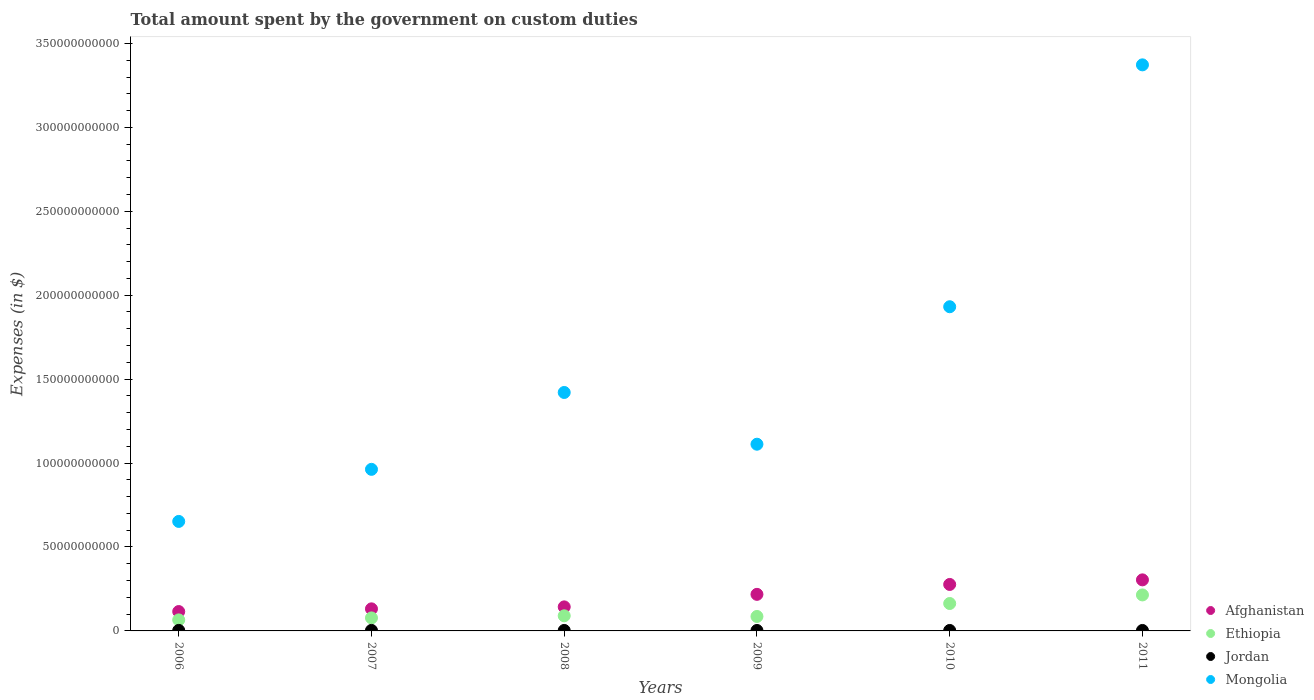How many different coloured dotlines are there?
Give a very brief answer. 4. Is the number of dotlines equal to the number of legend labels?
Your answer should be compact. Yes. What is the amount spent on custom duties by the government in Ethiopia in 2008?
Make the answer very short. 9.01e+09. Across all years, what is the maximum amount spent on custom duties by the government in Jordan?
Your answer should be compact. 3.16e+08. Across all years, what is the minimum amount spent on custom duties by the government in Afghanistan?
Your response must be concise. 1.15e+1. In which year was the amount spent on custom duties by the government in Afghanistan minimum?
Your response must be concise. 2006. What is the total amount spent on custom duties by the government in Jordan in the graph?
Ensure brevity in your answer.  1.73e+09. What is the difference between the amount spent on custom duties by the government in Ethiopia in 2007 and that in 2011?
Offer a very short reply. -1.37e+1. What is the difference between the amount spent on custom duties by the government in Jordan in 2006 and the amount spent on custom duties by the government in Mongolia in 2009?
Make the answer very short. -1.11e+11. What is the average amount spent on custom duties by the government in Jordan per year?
Give a very brief answer. 2.89e+08. In the year 2011, what is the difference between the amount spent on custom duties by the government in Afghanistan and amount spent on custom duties by the government in Jordan?
Your response must be concise. 3.01e+1. What is the ratio of the amount spent on custom duties by the government in Jordan in 2009 to that in 2011?
Your response must be concise. 0.99. Is the difference between the amount spent on custom duties by the government in Afghanistan in 2006 and 2009 greater than the difference between the amount spent on custom duties by the government in Jordan in 2006 and 2009?
Offer a very short reply. No. What is the difference between the highest and the second highest amount spent on custom duties by the government in Ethiopia?
Offer a terse response. 5.11e+09. What is the difference between the highest and the lowest amount spent on custom duties by the government in Afghanistan?
Ensure brevity in your answer.  1.89e+1. In how many years, is the amount spent on custom duties by the government in Afghanistan greater than the average amount spent on custom duties by the government in Afghanistan taken over all years?
Offer a terse response. 3. Is it the case that in every year, the sum of the amount spent on custom duties by the government in Mongolia and amount spent on custom duties by the government in Ethiopia  is greater than the sum of amount spent on custom duties by the government in Jordan and amount spent on custom duties by the government in Afghanistan?
Your response must be concise. Yes. Does the amount spent on custom duties by the government in Ethiopia monotonically increase over the years?
Keep it short and to the point. No. Is the amount spent on custom duties by the government in Afghanistan strictly greater than the amount spent on custom duties by the government in Jordan over the years?
Ensure brevity in your answer.  Yes. Is the amount spent on custom duties by the government in Jordan strictly less than the amount spent on custom duties by the government in Mongolia over the years?
Your answer should be very brief. Yes. Are the values on the major ticks of Y-axis written in scientific E-notation?
Your answer should be very brief. No. Does the graph contain any zero values?
Your answer should be very brief. No. Does the graph contain grids?
Offer a very short reply. No. How many legend labels are there?
Make the answer very short. 4. How are the legend labels stacked?
Provide a succinct answer. Vertical. What is the title of the graph?
Ensure brevity in your answer.  Total amount spent by the government on custom duties. Does "Mali" appear as one of the legend labels in the graph?
Give a very brief answer. No. What is the label or title of the X-axis?
Your response must be concise. Years. What is the label or title of the Y-axis?
Offer a terse response. Expenses (in $). What is the Expenses (in $) of Afghanistan in 2006?
Your answer should be compact. 1.15e+1. What is the Expenses (in $) in Ethiopia in 2006?
Provide a short and direct response. 6.57e+09. What is the Expenses (in $) of Jordan in 2006?
Ensure brevity in your answer.  3.16e+08. What is the Expenses (in $) of Mongolia in 2006?
Your response must be concise. 6.52e+1. What is the Expenses (in $) in Afghanistan in 2007?
Keep it short and to the point. 1.31e+1. What is the Expenses (in $) of Ethiopia in 2007?
Provide a short and direct response. 7.75e+09. What is the Expenses (in $) in Jordan in 2007?
Your answer should be very brief. 3.12e+08. What is the Expenses (in $) in Mongolia in 2007?
Provide a succinct answer. 9.63e+1. What is the Expenses (in $) in Afghanistan in 2008?
Offer a terse response. 1.43e+1. What is the Expenses (in $) of Ethiopia in 2008?
Ensure brevity in your answer.  9.01e+09. What is the Expenses (in $) in Jordan in 2008?
Provide a short and direct response. 2.84e+08. What is the Expenses (in $) in Mongolia in 2008?
Your answer should be compact. 1.42e+11. What is the Expenses (in $) of Afghanistan in 2009?
Ensure brevity in your answer.  2.18e+1. What is the Expenses (in $) of Ethiopia in 2009?
Keep it short and to the point. 8.62e+09. What is the Expenses (in $) in Jordan in 2009?
Ensure brevity in your answer.  2.70e+08. What is the Expenses (in $) in Mongolia in 2009?
Provide a succinct answer. 1.11e+11. What is the Expenses (in $) of Afghanistan in 2010?
Make the answer very short. 2.77e+1. What is the Expenses (in $) of Ethiopia in 2010?
Offer a very short reply. 1.63e+1. What is the Expenses (in $) of Jordan in 2010?
Your response must be concise. 2.75e+08. What is the Expenses (in $) in Mongolia in 2010?
Provide a succinct answer. 1.93e+11. What is the Expenses (in $) of Afghanistan in 2011?
Ensure brevity in your answer.  3.04e+1. What is the Expenses (in $) in Ethiopia in 2011?
Make the answer very short. 2.14e+1. What is the Expenses (in $) of Jordan in 2011?
Offer a very short reply. 2.74e+08. What is the Expenses (in $) of Mongolia in 2011?
Keep it short and to the point. 3.37e+11. Across all years, what is the maximum Expenses (in $) of Afghanistan?
Offer a terse response. 3.04e+1. Across all years, what is the maximum Expenses (in $) of Ethiopia?
Offer a terse response. 2.14e+1. Across all years, what is the maximum Expenses (in $) in Jordan?
Keep it short and to the point. 3.16e+08. Across all years, what is the maximum Expenses (in $) of Mongolia?
Provide a short and direct response. 3.37e+11. Across all years, what is the minimum Expenses (in $) in Afghanistan?
Provide a short and direct response. 1.15e+1. Across all years, what is the minimum Expenses (in $) in Ethiopia?
Your answer should be compact. 6.57e+09. Across all years, what is the minimum Expenses (in $) of Jordan?
Your answer should be compact. 2.70e+08. Across all years, what is the minimum Expenses (in $) in Mongolia?
Ensure brevity in your answer.  6.52e+1. What is the total Expenses (in $) of Afghanistan in the graph?
Provide a short and direct response. 1.19e+11. What is the total Expenses (in $) in Ethiopia in the graph?
Your answer should be compact. 6.97e+1. What is the total Expenses (in $) in Jordan in the graph?
Offer a terse response. 1.73e+09. What is the total Expenses (in $) of Mongolia in the graph?
Offer a very short reply. 9.45e+11. What is the difference between the Expenses (in $) of Afghanistan in 2006 and that in 2007?
Offer a terse response. -1.61e+09. What is the difference between the Expenses (in $) of Ethiopia in 2006 and that in 2007?
Make the answer very short. -1.18e+09. What is the difference between the Expenses (in $) of Jordan in 2006 and that in 2007?
Keep it short and to the point. 3.54e+06. What is the difference between the Expenses (in $) in Mongolia in 2006 and that in 2007?
Make the answer very short. -3.10e+1. What is the difference between the Expenses (in $) in Afghanistan in 2006 and that in 2008?
Provide a succinct answer. -2.79e+09. What is the difference between the Expenses (in $) of Ethiopia in 2006 and that in 2008?
Give a very brief answer. -2.44e+09. What is the difference between the Expenses (in $) in Jordan in 2006 and that in 2008?
Your answer should be compact. 3.12e+07. What is the difference between the Expenses (in $) of Mongolia in 2006 and that in 2008?
Your answer should be compact. -7.68e+1. What is the difference between the Expenses (in $) in Afghanistan in 2006 and that in 2009?
Give a very brief answer. -1.02e+1. What is the difference between the Expenses (in $) of Ethiopia in 2006 and that in 2009?
Give a very brief answer. -2.05e+09. What is the difference between the Expenses (in $) in Jordan in 2006 and that in 2009?
Offer a terse response. 4.53e+07. What is the difference between the Expenses (in $) of Mongolia in 2006 and that in 2009?
Your answer should be very brief. -4.60e+1. What is the difference between the Expenses (in $) of Afghanistan in 2006 and that in 2010?
Ensure brevity in your answer.  -1.61e+1. What is the difference between the Expenses (in $) in Ethiopia in 2006 and that in 2010?
Ensure brevity in your answer.  -9.77e+09. What is the difference between the Expenses (in $) of Jordan in 2006 and that in 2010?
Provide a succinct answer. 4.04e+07. What is the difference between the Expenses (in $) of Mongolia in 2006 and that in 2010?
Provide a succinct answer. -1.28e+11. What is the difference between the Expenses (in $) of Afghanistan in 2006 and that in 2011?
Keep it short and to the point. -1.89e+1. What is the difference between the Expenses (in $) of Ethiopia in 2006 and that in 2011?
Your response must be concise. -1.49e+1. What is the difference between the Expenses (in $) of Jordan in 2006 and that in 2011?
Offer a very short reply. 4.14e+07. What is the difference between the Expenses (in $) of Mongolia in 2006 and that in 2011?
Provide a short and direct response. -2.72e+11. What is the difference between the Expenses (in $) in Afghanistan in 2007 and that in 2008?
Offer a very short reply. -1.17e+09. What is the difference between the Expenses (in $) of Ethiopia in 2007 and that in 2008?
Your answer should be compact. -1.26e+09. What is the difference between the Expenses (in $) in Jordan in 2007 and that in 2008?
Offer a terse response. 2.77e+07. What is the difference between the Expenses (in $) in Mongolia in 2007 and that in 2008?
Make the answer very short. -4.58e+1. What is the difference between the Expenses (in $) of Afghanistan in 2007 and that in 2009?
Provide a succinct answer. -8.64e+09. What is the difference between the Expenses (in $) of Ethiopia in 2007 and that in 2009?
Ensure brevity in your answer.  -8.65e+08. What is the difference between the Expenses (in $) of Jordan in 2007 and that in 2009?
Offer a terse response. 4.18e+07. What is the difference between the Expenses (in $) in Mongolia in 2007 and that in 2009?
Provide a succinct answer. -1.50e+1. What is the difference between the Expenses (in $) of Afghanistan in 2007 and that in 2010?
Keep it short and to the point. -1.45e+1. What is the difference between the Expenses (in $) in Ethiopia in 2007 and that in 2010?
Your response must be concise. -8.58e+09. What is the difference between the Expenses (in $) in Jordan in 2007 and that in 2010?
Make the answer very short. 3.69e+07. What is the difference between the Expenses (in $) in Mongolia in 2007 and that in 2010?
Offer a very short reply. -9.69e+1. What is the difference between the Expenses (in $) of Afghanistan in 2007 and that in 2011?
Keep it short and to the point. -1.73e+1. What is the difference between the Expenses (in $) in Ethiopia in 2007 and that in 2011?
Provide a succinct answer. -1.37e+1. What is the difference between the Expenses (in $) in Jordan in 2007 and that in 2011?
Offer a terse response. 3.79e+07. What is the difference between the Expenses (in $) of Mongolia in 2007 and that in 2011?
Keep it short and to the point. -2.41e+11. What is the difference between the Expenses (in $) in Afghanistan in 2008 and that in 2009?
Make the answer very short. -7.46e+09. What is the difference between the Expenses (in $) in Ethiopia in 2008 and that in 2009?
Provide a succinct answer. 3.92e+08. What is the difference between the Expenses (in $) in Jordan in 2008 and that in 2009?
Your response must be concise. 1.41e+07. What is the difference between the Expenses (in $) of Mongolia in 2008 and that in 2009?
Offer a very short reply. 3.08e+1. What is the difference between the Expenses (in $) in Afghanistan in 2008 and that in 2010?
Your answer should be very brief. -1.34e+1. What is the difference between the Expenses (in $) in Ethiopia in 2008 and that in 2010?
Provide a succinct answer. -7.32e+09. What is the difference between the Expenses (in $) in Jordan in 2008 and that in 2010?
Your answer should be compact. 9.20e+06. What is the difference between the Expenses (in $) of Mongolia in 2008 and that in 2010?
Your response must be concise. -5.11e+1. What is the difference between the Expenses (in $) in Afghanistan in 2008 and that in 2011?
Provide a succinct answer. -1.61e+1. What is the difference between the Expenses (in $) of Ethiopia in 2008 and that in 2011?
Your answer should be compact. -1.24e+1. What is the difference between the Expenses (in $) in Jordan in 2008 and that in 2011?
Your answer should be compact. 1.02e+07. What is the difference between the Expenses (in $) in Mongolia in 2008 and that in 2011?
Your response must be concise. -1.95e+11. What is the difference between the Expenses (in $) in Afghanistan in 2009 and that in 2010?
Your answer should be compact. -5.90e+09. What is the difference between the Expenses (in $) of Ethiopia in 2009 and that in 2010?
Provide a succinct answer. -7.72e+09. What is the difference between the Expenses (in $) in Jordan in 2009 and that in 2010?
Ensure brevity in your answer.  -4.90e+06. What is the difference between the Expenses (in $) of Mongolia in 2009 and that in 2010?
Your answer should be compact. -8.19e+1. What is the difference between the Expenses (in $) of Afghanistan in 2009 and that in 2011?
Your answer should be compact. -8.63e+09. What is the difference between the Expenses (in $) of Ethiopia in 2009 and that in 2011?
Make the answer very short. -1.28e+1. What is the difference between the Expenses (in $) of Jordan in 2009 and that in 2011?
Provide a short and direct response. -3.90e+06. What is the difference between the Expenses (in $) in Mongolia in 2009 and that in 2011?
Give a very brief answer. -2.26e+11. What is the difference between the Expenses (in $) of Afghanistan in 2010 and that in 2011?
Keep it short and to the point. -2.73e+09. What is the difference between the Expenses (in $) of Ethiopia in 2010 and that in 2011?
Ensure brevity in your answer.  -5.11e+09. What is the difference between the Expenses (in $) in Jordan in 2010 and that in 2011?
Offer a terse response. 1.00e+06. What is the difference between the Expenses (in $) of Mongolia in 2010 and that in 2011?
Offer a terse response. -1.44e+11. What is the difference between the Expenses (in $) in Afghanistan in 2006 and the Expenses (in $) in Ethiopia in 2007?
Give a very brief answer. 3.79e+09. What is the difference between the Expenses (in $) of Afghanistan in 2006 and the Expenses (in $) of Jordan in 2007?
Your answer should be very brief. 1.12e+1. What is the difference between the Expenses (in $) of Afghanistan in 2006 and the Expenses (in $) of Mongolia in 2007?
Offer a terse response. -8.47e+1. What is the difference between the Expenses (in $) in Ethiopia in 2006 and the Expenses (in $) in Jordan in 2007?
Give a very brief answer. 6.26e+09. What is the difference between the Expenses (in $) of Ethiopia in 2006 and the Expenses (in $) of Mongolia in 2007?
Offer a terse response. -8.97e+1. What is the difference between the Expenses (in $) of Jordan in 2006 and the Expenses (in $) of Mongolia in 2007?
Ensure brevity in your answer.  -9.59e+1. What is the difference between the Expenses (in $) of Afghanistan in 2006 and the Expenses (in $) of Ethiopia in 2008?
Your answer should be very brief. 2.53e+09. What is the difference between the Expenses (in $) of Afghanistan in 2006 and the Expenses (in $) of Jordan in 2008?
Make the answer very short. 1.13e+1. What is the difference between the Expenses (in $) of Afghanistan in 2006 and the Expenses (in $) of Mongolia in 2008?
Provide a short and direct response. -1.31e+11. What is the difference between the Expenses (in $) of Ethiopia in 2006 and the Expenses (in $) of Jordan in 2008?
Make the answer very short. 6.28e+09. What is the difference between the Expenses (in $) in Ethiopia in 2006 and the Expenses (in $) in Mongolia in 2008?
Your response must be concise. -1.35e+11. What is the difference between the Expenses (in $) in Jordan in 2006 and the Expenses (in $) in Mongolia in 2008?
Ensure brevity in your answer.  -1.42e+11. What is the difference between the Expenses (in $) in Afghanistan in 2006 and the Expenses (in $) in Ethiopia in 2009?
Keep it short and to the point. 2.92e+09. What is the difference between the Expenses (in $) of Afghanistan in 2006 and the Expenses (in $) of Jordan in 2009?
Give a very brief answer. 1.13e+1. What is the difference between the Expenses (in $) of Afghanistan in 2006 and the Expenses (in $) of Mongolia in 2009?
Your answer should be compact. -9.97e+1. What is the difference between the Expenses (in $) in Ethiopia in 2006 and the Expenses (in $) in Jordan in 2009?
Provide a short and direct response. 6.30e+09. What is the difference between the Expenses (in $) in Ethiopia in 2006 and the Expenses (in $) in Mongolia in 2009?
Offer a terse response. -1.05e+11. What is the difference between the Expenses (in $) of Jordan in 2006 and the Expenses (in $) of Mongolia in 2009?
Provide a succinct answer. -1.11e+11. What is the difference between the Expenses (in $) in Afghanistan in 2006 and the Expenses (in $) in Ethiopia in 2010?
Give a very brief answer. -4.80e+09. What is the difference between the Expenses (in $) of Afghanistan in 2006 and the Expenses (in $) of Jordan in 2010?
Your answer should be very brief. 1.13e+1. What is the difference between the Expenses (in $) in Afghanistan in 2006 and the Expenses (in $) in Mongolia in 2010?
Ensure brevity in your answer.  -1.82e+11. What is the difference between the Expenses (in $) in Ethiopia in 2006 and the Expenses (in $) in Jordan in 2010?
Provide a short and direct response. 6.29e+09. What is the difference between the Expenses (in $) in Ethiopia in 2006 and the Expenses (in $) in Mongolia in 2010?
Give a very brief answer. -1.87e+11. What is the difference between the Expenses (in $) of Jordan in 2006 and the Expenses (in $) of Mongolia in 2010?
Make the answer very short. -1.93e+11. What is the difference between the Expenses (in $) of Afghanistan in 2006 and the Expenses (in $) of Ethiopia in 2011?
Keep it short and to the point. -9.90e+09. What is the difference between the Expenses (in $) of Afghanistan in 2006 and the Expenses (in $) of Jordan in 2011?
Provide a short and direct response. 1.13e+1. What is the difference between the Expenses (in $) of Afghanistan in 2006 and the Expenses (in $) of Mongolia in 2011?
Keep it short and to the point. -3.26e+11. What is the difference between the Expenses (in $) in Ethiopia in 2006 and the Expenses (in $) in Jordan in 2011?
Keep it short and to the point. 6.29e+09. What is the difference between the Expenses (in $) in Ethiopia in 2006 and the Expenses (in $) in Mongolia in 2011?
Ensure brevity in your answer.  -3.31e+11. What is the difference between the Expenses (in $) of Jordan in 2006 and the Expenses (in $) of Mongolia in 2011?
Offer a very short reply. -3.37e+11. What is the difference between the Expenses (in $) in Afghanistan in 2007 and the Expenses (in $) in Ethiopia in 2008?
Provide a short and direct response. 4.14e+09. What is the difference between the Expenses (in $) of Afghanistan in 2007 and the Expenses (in $) of Jordan in 2008?
Make the answer very short. 1.29e+1. What is the difference between the Expenses (in $) in Afghanistan in 2007 and the Expenses (in $) in Mongolia in 2008?
Ensure brevity in your answer.  -1.29e+11. What is the difference between the Expenses (in $) of Ethiopia in 2007 and the Expenses (in $) of Jordan in 2008?
Ensure brevity in your answer.  7.47e+09. What is the difference between the Expenses (in $) in Ethiopia in 2007 and the Expenses (in $) in Mongolia in 2008?
Your answer should be very brief. -1.34e+11. What is the difference between the Expenses (in $) in Jordan in 2007 and the Expenses (in $) in Mongolia in 2008?
Your answer should be very brief. -1.42e+11. What is the difference between the Expenses (in $) of Afghanistan in 2007 and the Expenses (in $) of Ethiopia in 2009?
Offer a very short reply. 4.53e+09. What is the difference between the Expenses (in $) in Afghanistan in 2007 and the Expenses (in $) in Jordan in 2009?
Give a very brief answer. 1.29e+1. What is the difference between the Expenses (in $) in Afghanistan in 2007 and the Expenses (in $) in Mongolia in 2009?
Provide a short and direct response. -9.81e+1. What is the difference between the Expenses (in $) in Ethiopia in 2007 and the Expenses (in $) in Jordan in 2009?
Your answer should be very brief. 7.48e+09. What is the difference between the Expenses (in $) of Ethiopia in 2007 and the Expenses (in $) of Mongolia in 2009?
Ensure brevity in your answer.  -1.03e+11. What is the difference between the Expenses (in $) of Jordan in 2007 and the Expenses (in $) of Mongolia in 2009?
Ensure brevity in your answer.  -1.11e+11. What is the difference between the Expenses (in $) in Afghanistan in 2007 and the Expenses (in $) in Ethiopia in 2010?
Provide a short and direct response. -3.19e+09. What is the difference between the Expenses (in $) in Afghanistan in 2007 and the Expenses (in $) in Jordan in 2010?
Give a very brief answer. 1.29e+1. What is the difference between the Expenses (in $) in Afghanistan in 2007 and the Expenses (in $) in Mongolia in 2010?
Your answer should be very brief. -1.80e+11. What is the difference between the Expenses (in $) in Ethiopia in 2007 and the Expenses (in $) in Jordan in 2010?
Ensure brevity in your answer.  7.48e+09. What is the difference between the Expenses (in $) in Ethiopia in 2007 and the Expenses (in $) in Mongolia in 2010?
Ensure brevity in your answer.  -1.85e+11. What is the difference between the Expenses (in $) of Jordan in 2007 and the Expenses (in $) of Mongolia in 2010?
Give a very brief answer. -1.93e+11. What is the difference between the Expenses (in $) of Afghanistan in 2007 and the Expenses (in $) of Ethiopia in 2011?
Provide a succinct answer. -8.29e+09. What is the difference between the Expenses (in $) in Afghanistan in 2007 and the Expenses (in $) in Jordan in 2011?
Provide a short and direct response. 1.29e+1. What is the difference between the Expenses (in $) in Afghanistan in 2007 and the Expenses (in $) in Mongolia in 2011?
Make the answer very short. -3.24e+11. What is the difference between the Expenses (in $) of Ethiopia in 2007 and the Expenses (in $) of Jordan in 2011?
Offer a terse response. 7.48e+09. What is the difference between the Expenses (in $) in Ethiopia in 2007 and the Expenses (in $) in Mongolia in 2011?
Offer a terse response. -3.29e+11. What is the difference between the Expenses (in $) of Jordan in 2007 and the Expenses (in $) of Mongolia in 2011?
Keep it short and to the point. -3.37e+11. What is the difference between the Expenses (in $) in Afghanistan in 2008 and the Expenses (in $) in Ethiopia in 2009?
Make the answer very short. 5.71e+09. What is the difference between the Expenses (in $) of Afghanistan in 2008 and the Expenses (in $) of Jordan in 2009?
Keep it short and to the point. 1.41e+1. What is the difference between the Expenses (in $) in Afghanistan in 2008 and the Expenses (in $) in Mongolia in 2009?
Your answer should be compact. -9.69e+1. What is the difference between the Expenses (in $) in Ethiopia in 2008 and the Expenses (in $) in Jordan in 2009?
Offer a terse response. 8.74e+09. What is the difference between the Expenses (in $) of Ethiopia in 2008 and the Expenses (in $) of Mongolia in 2009?
Offer a very short reply. -1.02e+11. What is the difference between the Expenses (in $) of Jordan in 2008 and the Expenses (in $) of Mongolia in 2009?
Your response must be concise. -1.11e+11. What is the difference between the Expenses (in $) in Afghanistan in 2008 and the Expenses (in $) in Ethiopia in 2010?
Make the answer very short. -2.01e+09. What is the difference between the Expenses (in $) in Afghanistan in 2008 and the Expenses (in $) in Jordan in 2010?
Your answer should be very brief. 1.40e+1. What is the difference between the Expenses (in $) of Afghanistan in 2008 and the Expenses (in $) of Mongolia in 2010?
Ensure brevity in your answer.  -1.79e+11. What is the difference between the Expenses (in $) in Ethiopia in 2008 and the Expenses (in $) in Jordan in 2010?
Give a very brief answer. 8.73e+09. What is the difference between the Expenses (in $) in Ethiopia in 2008 and the Expenses (in $) in Mongolia in 2010?
Offer a terse response. -1.84e+11. What is the difference between the Expenses (in $) in Jordan in 2008 and the Expenses (in $) in Mongolia in 2010?
Your answer should be compact. -1.93e+11. What is the difference between the Expenses (in $) of Afghanistan in 2008 and the Expenses (in $) of Ethiopia in 2011?
Ensure brevity in your answer.  -7.12e+09. What is the difference between the Expenses (in $) in Afghanistan in 2008 and the Expenses (in $) in Jordan in 2011?
Make the answer very short. 1.40e+1. What is the difference between the Expenses (in $) in Afghanistan in 2008 and the Expenses (in $) in Mongolia in 2011?
Keep it short and to the point. -3.23e+11. What is the difference between the Expenses (in $) in Ethiopia in 2008 and the Expenses (in $) in Jordan in 2011?
Your answer should be very brief. 8.74e+09. What is the difference between the Expenses (in $) of Ethiopia in 2008 and the Expenses (in $) of Mongolia in 2011?
Ensure brevity in your answer.  -3.28e+11. What is the difference between the Expenses (in $) in Jordan in 2008 and the Expenses (in $) in Mongolia in 2011?
Give a very brief answer. -3.37e+11. What is the difference between the Expenses (in $) in Afghanistan in 2009 and the Expenses (in $) in Ethiopia in 2010?
Keep it short and to the point. 5.45e+09. What is the difference between the Expenses (in $) of Afghanistan in 2009 and the Expenses (in $) of Jordan in 2010?
Keep it short and to the point. 2.15e+1. What is the difference between the Expenses (in $) of Afghanistan in 2009 and the Expenses (in $) of Mongolia in 2010?
Provide a succinct answer. -1.71e+11. What is the difference between the Expenses (in $) in Ethiopia in 2009 and the Expenses (in $) in Jordan in 2010?
Make the answer very short. 8.34e+09. What is the difference between the Expenses (in $) in Ethiopia in 2009 and the Expenses (in $) in Mongolia in 2010?
Provide a short and direct response. -1.85e+11. What is the difference between the Expenses (in $) of Jordan in 2009 and the Expenses (in $) of Mongolia in 2010?
Offer a terse response. -1.93e+11. What is the difference between the Expenses (in $) of Afghanistan in 2009 and the Expenses (in $) of Ethiopia in 2011?
Provide a short and direct response. 3.47e+08. What is the difference between the Expenses (in $) of Afghanistan in 2009 and the Expenses (in $) of Jordan in 2011?
Ensure brevity in your answer.  2.15e+1. What is the difference between the Expenses (in $) of Afghanistan in 2009 and the Expenses (in $) of Mongolia in 2011?
Your answer should be compact. -3.15e+11. What is the difference between the Expenses (in $) of Ethiopia in 2009 and the Expenses (in $) of Jordan in 2011?
Make the answer very short. 8.34e+09. What is the difference between the Expenses (in $) in Ethiopia in 2009 and the Expenses (in $) in Mongolia in 2011?
Your response must be concise. -3.29e+11. What is the difference between the Expenses (in $) in Jordan in 2009 and the Expenses (in $) in Mongolia in 2011?
Offer a very short reply. -3.37e+11. What is the difference between the Expenses (in $) of Afghanistan in 2010 and the Expenses (in $) of Ethiopia in 2011?
Provide a short and direct response. 6.24e+09. What is the difference between the Expenses (in $) of Afghanistan in 2010 and the Expenses (in $) of Jordan in 2011?
Your answer should be very brief. 2.74e+1. What is the difference between the Expenses (in $) in Afghanistan in 2010 and the Expenses (in $) in Mongolia in 2011?
Make the answer very short. -3.10e+11. What is the difference between the Expenses (in $) in Ethiopia in 2010 and the Expenses (in $) in Jordan in 2011?
Offer a very short reply. 1.61e+1. What is the difference between the Expenses (in $) in Ethiopia in 2010 and the Expenses (in $) in Mongolia in 2011?
Keep it short and to the point. -3.21e+11. What is the difference between the Expenses (in $) of Jordan in 2010 and the Expenses (in $) of Mongolia in 2011?
Provide a succinct answer. -3.37e+11. What is the average Expenses (in $) of Afghanistan per year?
Ensure brevity in your answer.  1.98e+1. What is the average Expenses (in $) of Ethiopia per year?
Provide a succinct answer. 1.16e+1. What is the average Expenses (in $) of Jordan per year?
Offer a very short reply. 2.89e+08. What is the average Expenses (in $) of Mongolia per year?
Offer a very short reply. 1.58e+11. In the year 2006, what is the difference between the Expenses (in $) of Afghanistan and Expenses (in $) of Ethiopia?
Keep it short and to the point. 4.97e+09. In the year 2006, what is the difference between the Expenses (in $) in Afghanistan and Expenses (in $) in Jordan?
Your answer should be compact. 1.12e+1. In the year 2006, what is the difference between the Expenses (in $) in Afghanistan and Expenses (in $) in Mongolia?
Provide a succinct answer. -5.37e+1. In the year 2006, what is the difference between the Expenses (in $) in Ethiopia and Expenses (in $) in Jordan?
Offer a very short reply. 6.25e+09. In the year 2006, what is the difference between the Expenses (in $) of Ethiopia and Expenses (in $) of Mongolia?
Make the answer very short. -5.87e+1. In the year 2006, what is the difference between the Expenses (in $) in Jordan and Expenses (in $) in Mongolia?
Provide a short and direct response. -6.49e+1. In the year 2007, what is the difference between the Expenses (in $) in Afghanistan and Expenses (in $) in Ethiopia?
Make the answer very short. 5.40e+09. In the year 2007, what is the difference between the Expenses (in $) of Afghanistan and Expenses (in $) of Jordan?
Make the answer very short. 1.28e+1. In the year 2007, what is the difference between the Expenses (in $) of Afghanistan and Expenses (in $) of Mongolia?
Provide a short and direct response. -8.31e+1. In the year 2007, what is the difference between the Expenses (in $) of Ethiopia and Expenses (in $) of Jordan?
Keep it short and to the point. 7.44e+09. In the year 2007, what is the difference between the Expenses (in $) in Ethiopia and Expenses (in $) in Mongolia?
Keep it short and to the point. -8.85e+1. In the year 2007, what is the difference between the Expenses (in $) in Jordan and Expenses (in $) in Mongolia?
Provide a succinct answer. -9.60e+1. In the year 2008, what is the difference between the Expenses (in $) in Afghanistan and Expenses (in $) in Ethiopia?
Provide a succinct answer. 5.31e+09. In the year 2008, what is the difference between the Expenses (in $) in Afghanistan and Expenses (in $) in Jordan?
Provide a short and direct response. 1.40e+1. In the year 2008, what is the difference between the Expenses (in $) of Afghanistan and Expenses (in $) of Mongolia?
Ensure brevity in your answer.  -1.28e+11. In the year 2008, what is the difference between the Expenses (in $) in Ethiopia and Expenses (in $) in Jordan?
Give a very brief answer. 8.73e+09. In the year 2008, what is the difference between the Expenses (in $) of Ethiopia and Expenses (in $) of Mongolia?
Keep it short and to the point. -1.33e+11. In the year 2008, what is the difference between the Expenses (in $) in Jordan and Expenses (in $) in Mongolia?
Give a very brief answer. -1.42e+11. In the year 2009, what is the difference between the Expenses (in $) of Afghanistan and Expenses (in $) of Ethiopia?
Keep it short and to the point. 1.32e+1. In the year 2009, what is the difference between the Expenses (in $) in Afghanistan and Expenses (in $) in Jordan?
Make the answer very short. 2.15e+1. In the year 2009, what is the difference between the Expenses (in $) in Afghanistan and Expenses (in $) in Mongolia?
Ensure brevity in your answer.  -8.94e+1. In the year 2009, what is the difference between the Expenses (in $) of Ethiopia and Expenses (in $) of Jordan?
Provide a short and direct response. 8.35e+09. In the year 2009, what is the difference between the Expenses (in $) in Ethiopia and Expenses (in $) in Mongolia?
Offer a terse response. -1.03e+11. In the year 2009, what is the difference between the Expenses (in $) in Jordan and Expenses (in $) in Mongolia?
Make the answer very short. -1.11e+11. In the year 2010, what is the difference between the Expenses (in $) in Afghanistan and Expenses (in $) in Ethiopia?
Ensure brevity in your answer.  1.14e+1. In the year 2010, what is the difference between the Expenses (in $) in Afghanistan and Expenses (in $) in Jordan?
Your answer should be compact. 2.74e+1. In the year 2010, what is the difference between the Expenses (in $) of Afghanistan and Expenses (in $) of Mongolia?
Give a very brief answer. -1.65e+11. In the year 2010, what is the difference between the Expenses (in $) in Ethiopia and Expenses (in $) in Jordan?
Make the answer very short. 1.61e+1. In the year 2010, what is the difference between the Expenses (in $) in Ethiopia and Expenses (in $) in Mongolia?
Keep it short and to the point. -1.77e+11. In the year 2010, what is the difference between the Expenses (in $) of Jordan and Expenses (in $) of Mongolia?
Your answer should be very brief. -1.93e+11. In the year 2011, what is the difference between the Expenses (in $) of Afghanistan and Expenses (in $) of Ethiopia?
Offer a very short reply. 8.98e+09. In the year 2011, what is the difference between the Expenses (in $) of Afghanistan and Expenses (in $) of Jordan?
Offer a very short reply. 3.01e+1. In the year 2011, what is the difference between the Expenses (in $) of Afghanistan and Expenses (in $) of Mongolia?
Provide a succinct answer. -3.07e+11. In the year 2011, what is the difference between the Expenses (in $) in Ethiopia and Expenses (in $) in Jordan?
Offer a terse response. 2.12e+1. In the year 2011, what is the difference between the Expenses (in $) in Ethiopia and Expenses (in $) in Mongolia?
Your answer should be very brief. -3.16e+11. In the year 2011, what is the difference between the Expenses (in $) in Jordan and Expenses (in $) in Mongolia?
Your answer should be compact. -3.37e+11. What is the ratio of the Expenses (in $) in Afghanistan in 2006 to that in 2007?
Your response must be concise. 0.88. What is the ratio of the Expenses (in $) in Ethiopia in 2006 to that in 2007?
Your answer should be compact. 0.85. What is the ratio of the Expenses (in $) in Jordan in 2006 to that in 2007?
Your answer should be very brief. 1.01. What is the ratio of the Expenses (in $) in Mongolia in 2006 to that in 2007?
Make the answer very short. 0.68. What is the ratio of the Expenses (in $) of Afghanistan in 2006 to that in 2008?
Offer a terse response. 0.81. What is the ratio of the Expenses (in $) in Ethiopia in 2006 to that in 2008?
Your answer should be very brief. 0.73. What is the ratio of the Expenses (in $) of Jordan in 2006 to that in 2008?
Offer a very short reply. 1.11. What is the ratio of the Expenses (in $) of Mongolia in 2006 to that in 2008?
Provide a short and direct response. 0.46. What is the ratio of the Expenses (in $) of Afghanistan in 2006 to that in 2009?
Keep it short and to the point. 0.53. What is the ratio of the Expenses (in $) of Ethiopia in 2006 to that in 2009?
Keep it short and to the point. 0.76. What is the ratio of the Expenses (in $) of Jordan in 2006 to that in 2009?
Offer a very short reply. 1.17. What is the ratio of the Expenses (in $) in Mongolia in 2006 to that in 2009?
Give a very brief answer. 0.59. What is the ratio of the Expenses (in $) in Afghanistan in 2006 to that in 2010?
Ensure brevity in your answer.  0.42. What is the ratio of the Expenses (in $) in Ethiopia in 2006 to that in 2010?
Keep it short and to the point. 0.4. What is the ratio of the Expenses (in $) of Jordan in 2006 to that in 2010?
Give a very brief answer. 1.15. What is the ratio of the Expenses (in $) of Mongolia in 2006 to that in 2010?
Make the answer very short. 0.34. What is the ratio of the Expenses (in $) in Afghanistan in 2006 to that in 2011?
Make the answer very short. 0.38. What is the ratio of the Expenses (in $) in Ethiopia in 2006 to that in 2011?
Provide a short and direct response. 0.31. What is the ratio of the Expenses (in $) in Jordan in 2006 to that in 2011?
Your answer should be compact. 1.15. What is the ratio of the Expenses (in $) of Mongolia in 2006 to that in 2011?
Provide a succinct answer. 0.19. What is the ratio of the Expenses (in $) of Afghanistan in 2007 to that in 2008?
Make the answer very short. 0.92. What is the ratio of the Expenses (in $) in Ethiopia in 2007 to that in 2008?
Ensure brevity in your answer.  0.86. What is the ratio of the Expenses (in $) in Jordan in 2007 to that in 2008?
Your answer should be compact. 1.1. What is the ratio of the Expenses (in $) in Mongolia in 2007 to that in 2008?
Keep it short and to the point. 0.68. What is the ratio of the Expenses (in $) of Afghanistan in 2007 to that in 2009?
Provide a short and direct response. 0.6. What is the ratio of the Expenses (in $) of Ethiopia in 2007 to that in 2009?
Offer a very short reply. 0.9. What is the ratio of the Expenses (in $) in Jordan in 2007 to that in 2009?
Provide a succinct answer. 1.15. What is the ratio of the Expenses (in $) of Mongolia in 2007 to that in 2009?
Provide a short and direct response. 0.87. What is the ratio of the Expenses (in $) of Afghanistan in 2007 to that in 2010?
Make the answer very short. 0.47. What is the ratio of the Expenses (in $) of Ethiopia in 2007 to that in 2010?
Provide a succinct answer. 0.47. What is the ratio of the Expenses (in $) in Jordan in 2007 to that in 2010?
Make the answer very short. 1.13. What is the ratio of the Expenses (in $) of Mongolia in 2007 to that in 2010?
Provide a short and direct response. 0.5. What is the ratio of the Expenses (in $) of Afghanistan in 2007 to that in 2011?
Your response must be concise. 0.43. What is the ratio of the Expenses (in $) in Ethiopia in 2007 to that in 2011?
Offer a terse response. 0.36. What is the ratio of the Expenses (in $) in Jordan in 2007 to that in 2011?
Keep it short and to the point. 1.14. What is the ratio of the Expenses (in $) of Mongolia in 2007 to that in 2011?
Give a very brief answer. 0.29. What is the ratio of the Expenses (in $) in Afghanistan in 2008 to that in 2009?
Offer a terse response. 0.66. What is the ratio of the Expenses (in $) in Ethiopia in 2008 to that in 2009?
Ensure brevity in your answer.  1.05. What is the ratio of the Expenses (in $) of Jordan in 2008 to that in 2009?
Give a very brief answer. 1.05. What is the ratio of the Expenses (in $) of Mongolia in 2008 to that in 2009?
Provide a succinct answer. 1.28. What is the ratio of the Expenses (in $) of Afghanistan in 2008 to that in 2010?
Make the answer very short. 0.52. What is the ratio of the Expenses (in $) in Ethiopia in 2008 to that in 2010?
Offer a terse response. 0.55. What is the ratio of the Expenses (in $) of Jordan in 2008 to that in 2010?
Offer a very short reply. 1.03. What is the ratio of the Expenses (in $) in Mongolia in 2008 to that in 2010?
Your response must be concise. 0.74. What is the ratio of the Expenses (in $) in Afghanistan in 2008 to that in 2011?
Offer a terse response. 0.47. What is the ratio of the Expenses (in $) of Ethiopia in 2008 to that in 2011?
Give a very brief answer. 0.42. What is the ratio of the Expenses (in $) in Jordan in 2008 to that in 2011?
Offer a terse response. 1.04. What is the ratio of the Expenses (in $) of Mongolia in 2008 to that in 2011?
Ensure brevity in your answer.  0.42. What is the ratio of the Expenses (in $) of Afghanistan in 2009 to that in 2010?
Make the answer very short. 0.79. What is the ratio of the Expenses (in $) of Ethiopia in 2009 to that in 2010?
Your answer should be very brief. 0.53. What is the ratio of the Expenses (in $) in Jordan in 2009 to that in 2010?
Your response must be concise. 0.98. What is the ratio of the Expenses (in $) in Mongolia in 2009 to that in 2010?
Ensure brevity in your answer.  0.58. What is the ratio of the Expenses (in $) of Afghanistan in 2009 to that in 2011?
Give a very brief answer. 0.72. What is the ratio of the Expenses (in $) of Ethiopia in 2009 to that in 2011?
Offer a very short reply. 0.4. What is the ratio of the Expenses (in $) in Jordan in 2009 to that in 2011?
Your response must be concise. 0.99. What is the ratio of the Expenses (in $) in Mongolia in 2009 to that in 2011?
Provide a short and direct response. 0.33. What is the ratio of the Expenses (in $) of Afghanistan in 2010 to that in 2011?
Provide a succinct answer. 0.91. What is the ratio of the Expenses (in $) of Ethiopia in 2010 to that in 2011?
Offer a very short reply. 0.76. What is the ratio of the Expenses (in $) in Jordan in 2010 to that in 2011?
Make the answer very short. 1. What is the ratio of the Expenses (in $) of Mongolia in 2010 to that in 2011?
Offer a very short reply. 0.57. What is the difference between the highest and the second highest Expenses (in $) in Afghanistan?
Your response must be concise. 2.73e+09. What is the difference between the highest and the second highest Expenses (in $) of Ethiopia?
Your response must be concise. 5.11e+09. What is the difference between the highest and the second highest Expenses (in $) of Jordan?
Offer a very short reply. 3.54e+06. What is the difference between the highest and the second highest Expenses (in $) in Mongolia?
Give a very brief answer. 1.44e+11. What is the difference between the highest and the lowest Expenses (in $) of Afghanistan?
Your response must be concise. 1.89e+1. What is the difference between the highest and the lowest Expenses (in $) of Ethiopia?
Ensure brevity in your answer.  1.49e+1. What is the difference between the highest and the lowest Expenses (in $) of Jordan?
Your response must be concise. 4.53e+07. What is the difference between the highest and the lowest Expenses (in $) in Mongolia?
Your response must be concise. 2.72e+11. 